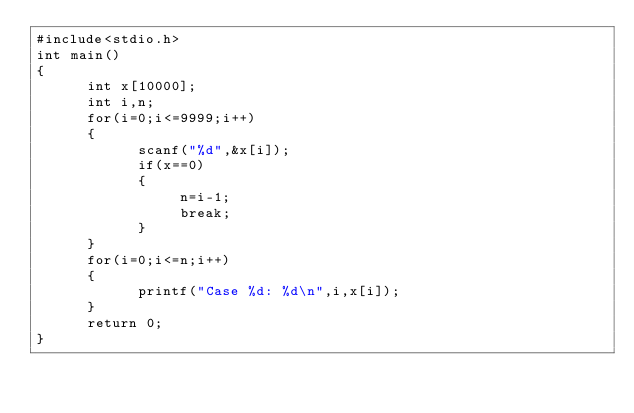Convert code to text. <code><loc_0><loc_0><loc_500><loc_500><_C_>#include<stdio.h>
int main()
{
      int x[10000];
      int i,n;
      for(i=0;i<=9999;i++)
      {
            scanf("%d",&x[i]);
            if(x==0)
            {
                 n=i-1;
                 break;
            }
      }
      for(i=0;i<=n;i++)
      {
            printf("Case %d: %d\n",i,x[i]);
      }
      return 0;
}</code> 